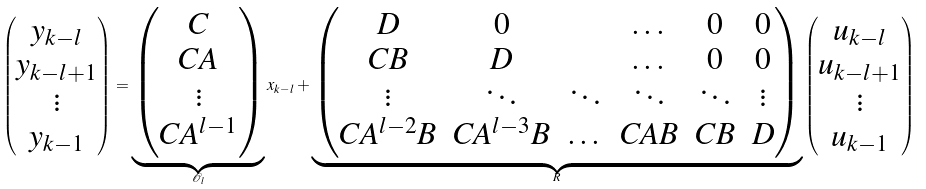<formula> <loc_0><loc_0><loc_500><loc_500>\begin{pmatrix} y _ { k - l } \\ y _ { k - l + 1 } \\ \vdots \\ y _ { k - 1 } \end{pmatrix} = \underbrace { \begin{pmatrix} C \\ C A \\ \vdots \\ C A ^ { l - 1 } \end{pmatrix} } _ { \mathcal { O } _ { l } } x _ { k - l } + \underbrace { \begin{pmatrix} D & 0 & & \dots & 0 & 0 \\ C B & D & & \dots & 0 & 0 \\ \vdots & \ddots & \ddots & \ddots & \ddots & \vdots \\ C A ^ { l - 2 } B & C A ^ { l - 3 } B & \dots & C A B & C B & D \end{pmatrix} } _ { R } \begin{pmatrix} u _ { k - l } \\ u _ { k - l + 1 } \\ \vdots \\ u _ { k - 1 } \end{pmatrix}</formula> 